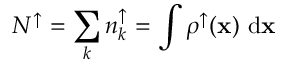<formula> <loc_0><loc_0><loc_500><loc_500>N ^ { \uparrow } = \sum _ { k } { n _ { k } ^ { \uparrow } } = \int { \rho ^ { \uparrow } ( { x } ) \ d { x } }</formula> 